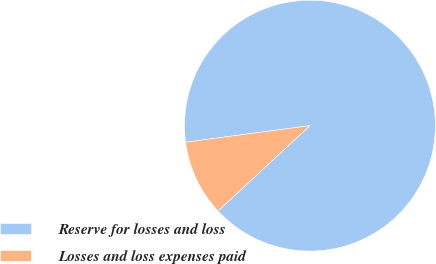Convert chart. <chart><loc_0><loc_0><loc_500><loc_500><pie_chart><fcel>Reserve for losses and loss<fcel>Losses and loss expenses paid<nl><fcel>90.2%<fcel>9.8%<nl></chart> 